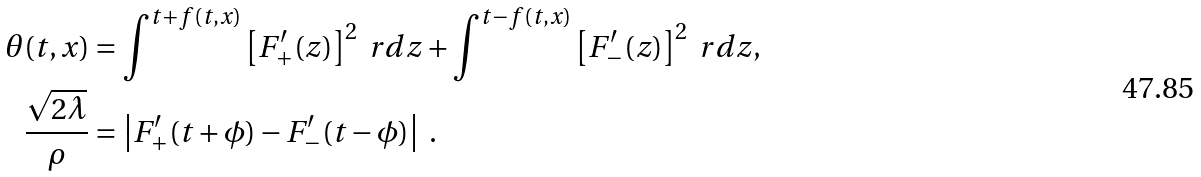<formula> <loc_0><loc_0><loc_500><loc_500>\theta ( t , x ) & = \int ^ { t + f ( t , x ) } \left [ F ^ { \prime } _ { + } ( z ) \right ] ^ { 2 } \ r d z + \int ^ { t - f ( t , x ) } \left [ F ^ { \prime } _ { - } ( z ) \right ] ^ { 2 } \ r d z , \\ \frac { \sqrt { 2 \lambda } } \rho & = \left | F ^ { \prime } _ { + } ( t + \phi ) - F ^ { \prime } _ { - } ( t - \phi ) \right | \ .</formula> 